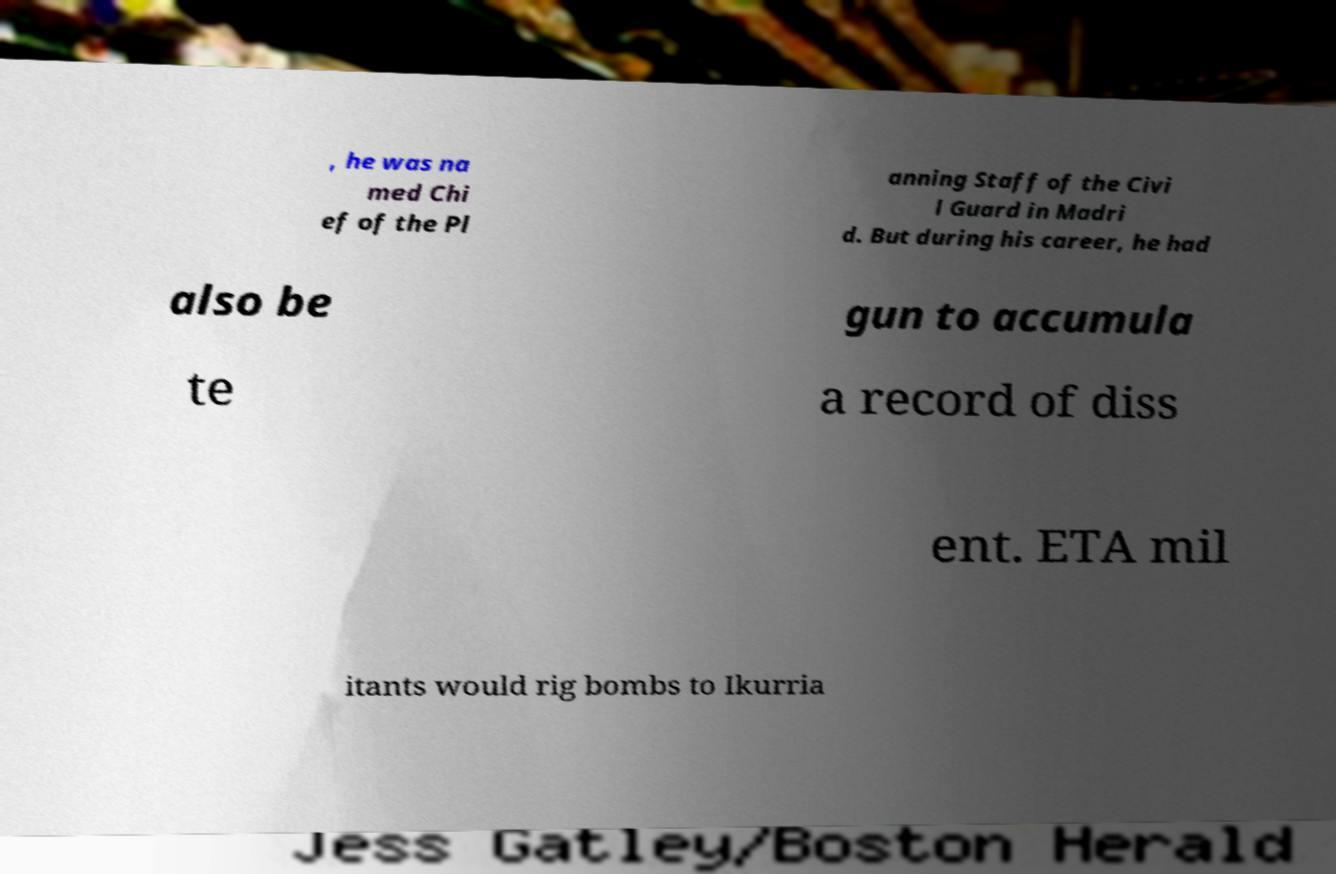There's text embedded in this image that I need extracted. Can you transcribe it verbatim? , he was na med Chi ef of the Pl anning Staff of the Civi l Guard in Madri d. But during his career, he had also be gun to accumula te a record of diss ent. ETA mil itants would rig bombs to Ikurria 